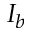<formula> <loc_0><loc_0><loc_500><loc_500>I _ { b }</formula> 